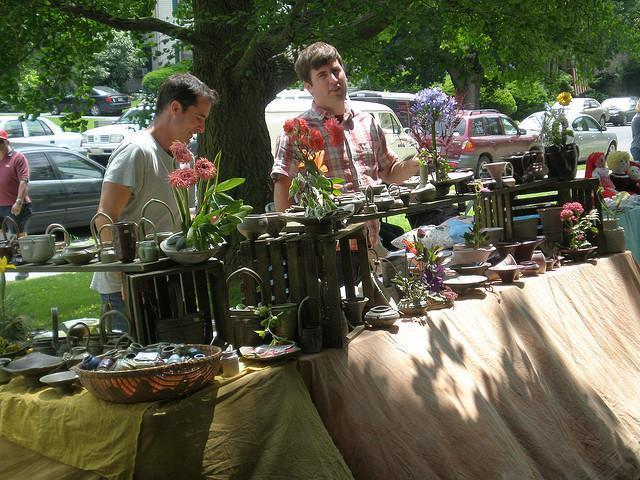What items are being shown off most frequently here?
Make your selection from the four choices given to correctly answer the question.
Options: Door knobs, green plants, boxes, pottery. Pottery. 